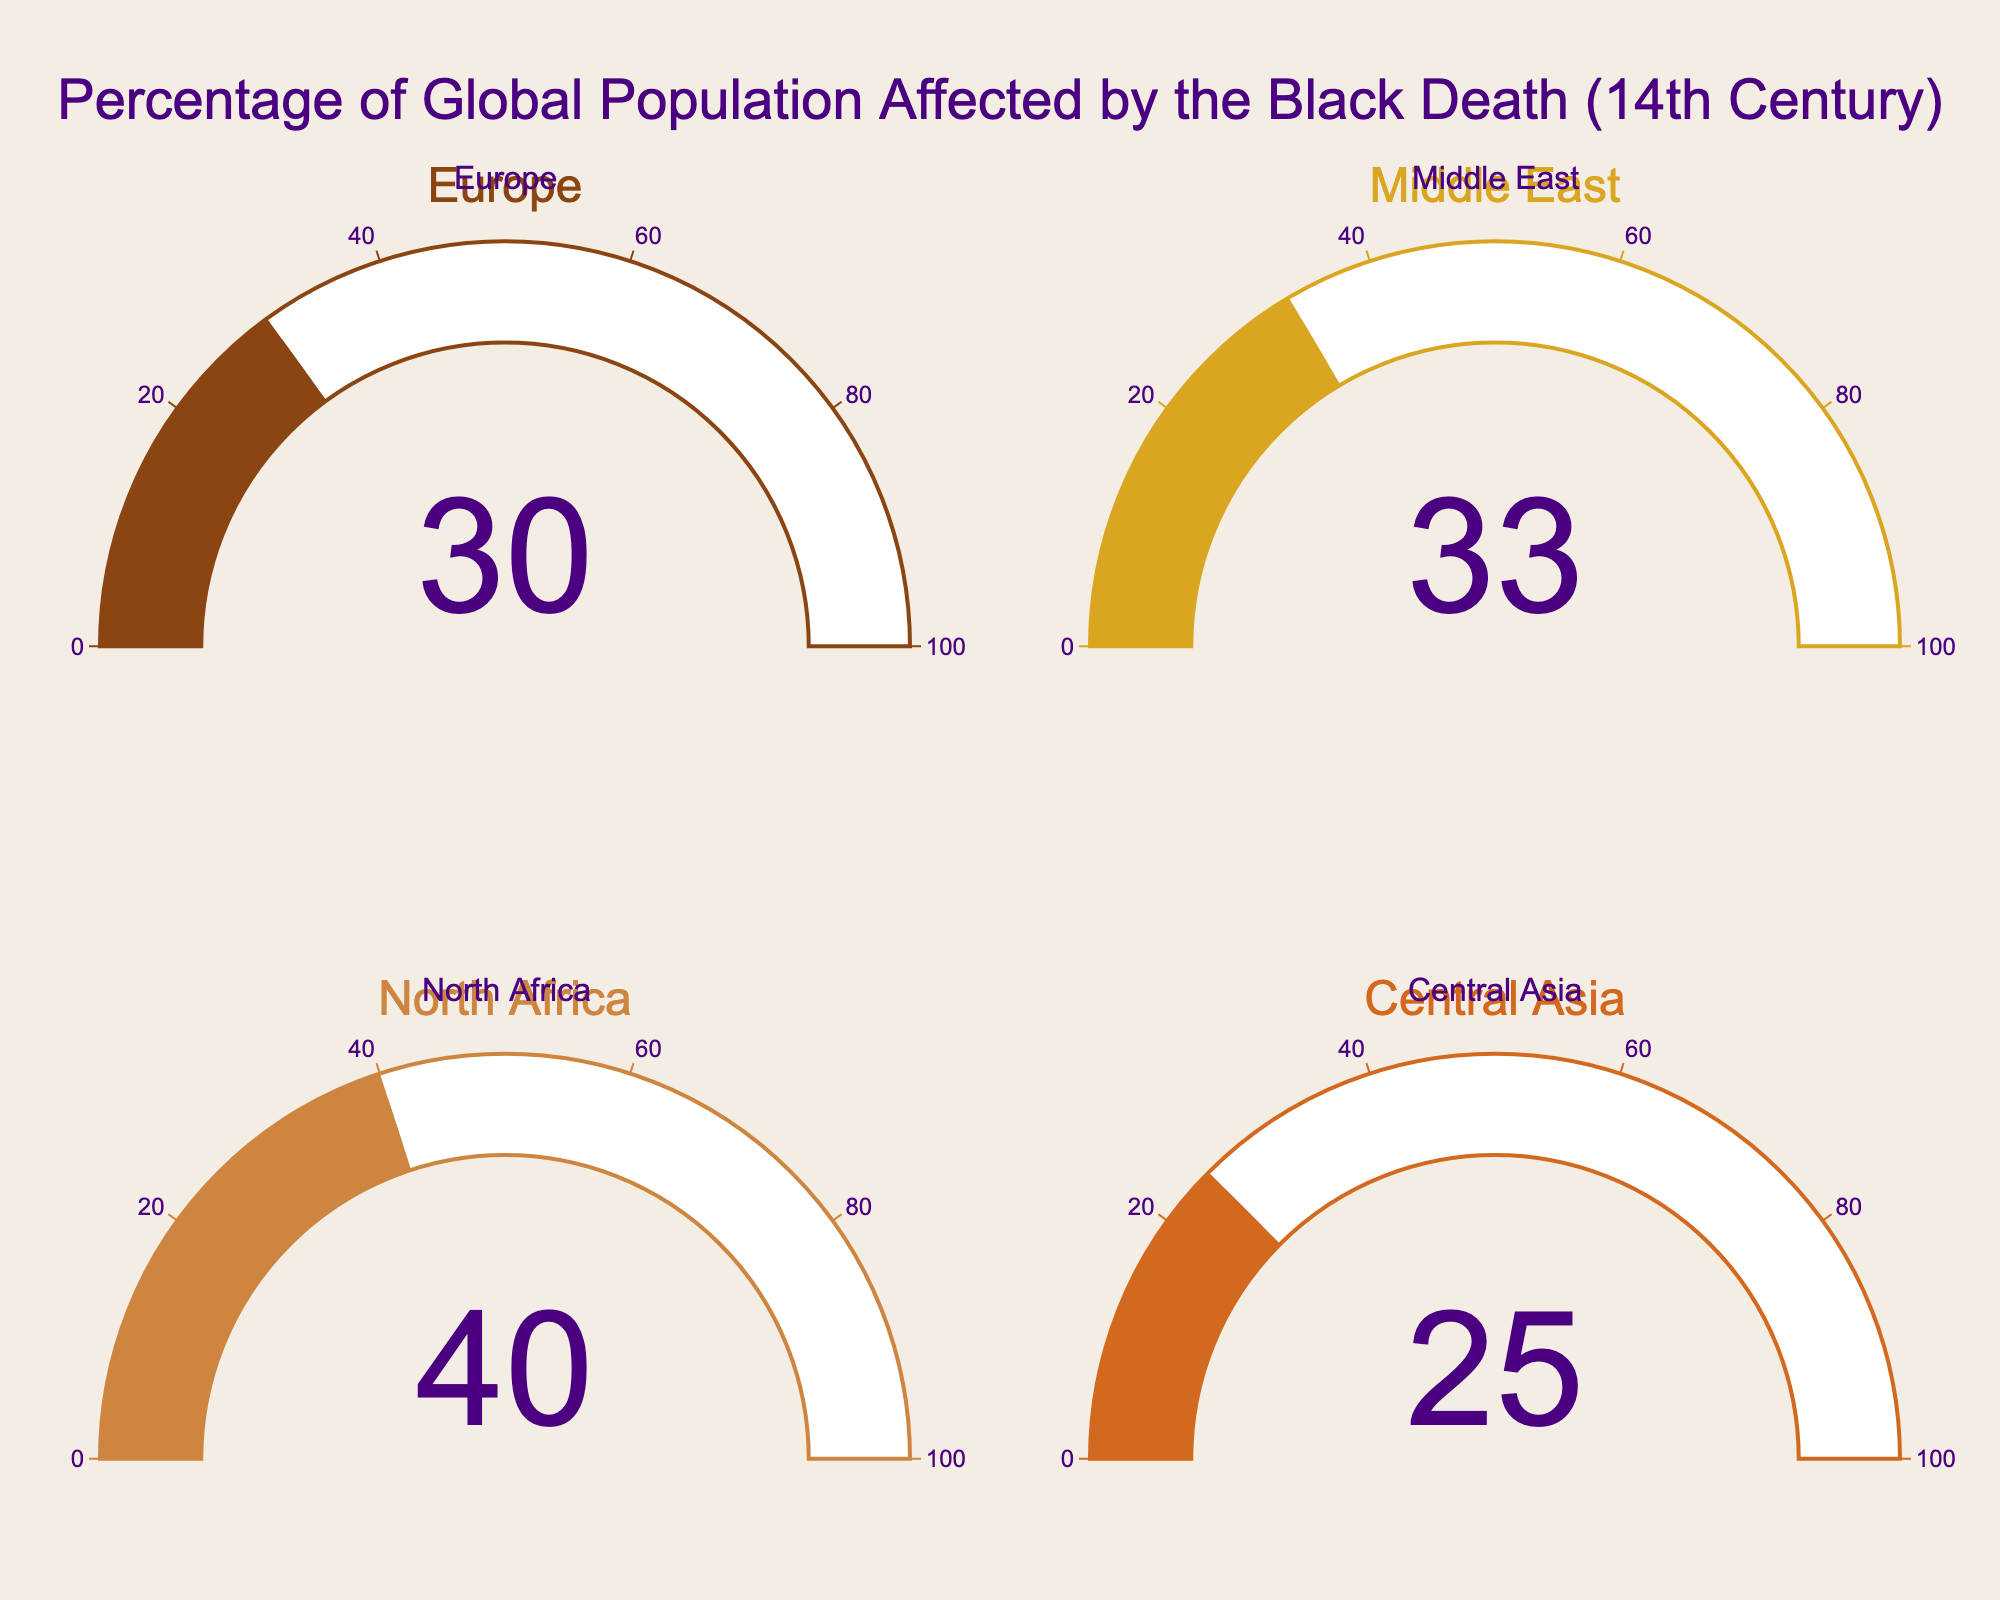What's the title of the figure? The title of the figure is displayed at the top, and it reads "Percentage of Global Population Affected by the Black Death (14th Century)."
Answer: Percentage of Global Population Affected by the Black Death (14th Century) Which region had the highest percentage of its population affected by the Black Death? By observing the gauge charts, North Africa has the highest value at 40%.
Answer: North Africa What's the total percentage of populations affected across all regions presented? Adding the percentages from all four regions: Europe (30) + Middle East (33) + North Africa (40) + Central Asia (25) gives 128.
Answer: 128% Which region had a population percentage affected closest to 30%? By looking at the values on the gauge charts, the region with a percentage closest to 30% is Europe, which has exactly 30%.
Answer: Europe What’s the difference in the percentage of populations affected between North Africa and Central Asia? Subtracting the percentage for Central Asia (25%) from that of North Africa (40%) gives 15%.
Answer: 15% Which two regions have the most similar percentages of populations affected by the Black Death? Comparing the values, Europe (30%) and Central Asia (25%) are the closest in their percentages with a difference of 5%.
Answer: Europe and Central Asia What’s the average percentage of populations affected across the given regions? Adding the percentages 30, 33, 40, and 25 gives a total of 128. Dividing by 4 regions gives an average of 32%.
Answer: 32% Is there any region where the gauge color has a shade similar to gold? The gauge for the Middle East uses a color that closely resembles gold.
Answer: Middle East Which region’s gauge chart displays the darkest color? The gauge chart for Europe displays the darkest color compared to the other regions.
Answer: Europe 